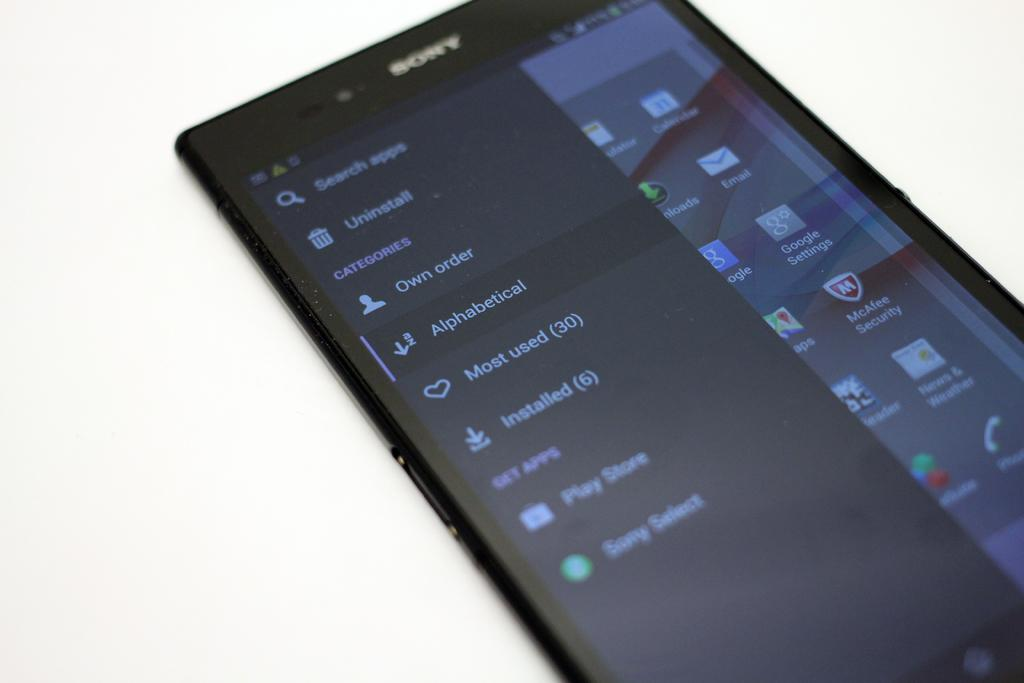<image>
Render a clear and concise summary of the photo. a sony phone with the search bar open to remove or find an app 